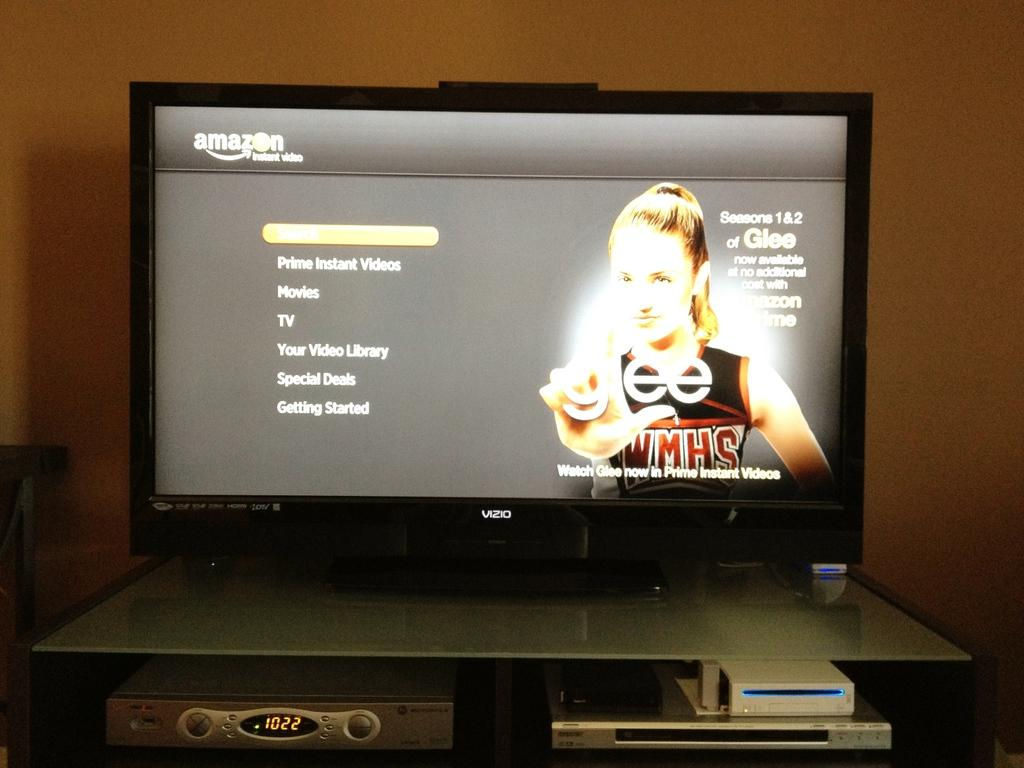Provide a one-sentence caption for the provided image. An Amazon prime menu that advertises the sitcom "Glee". 